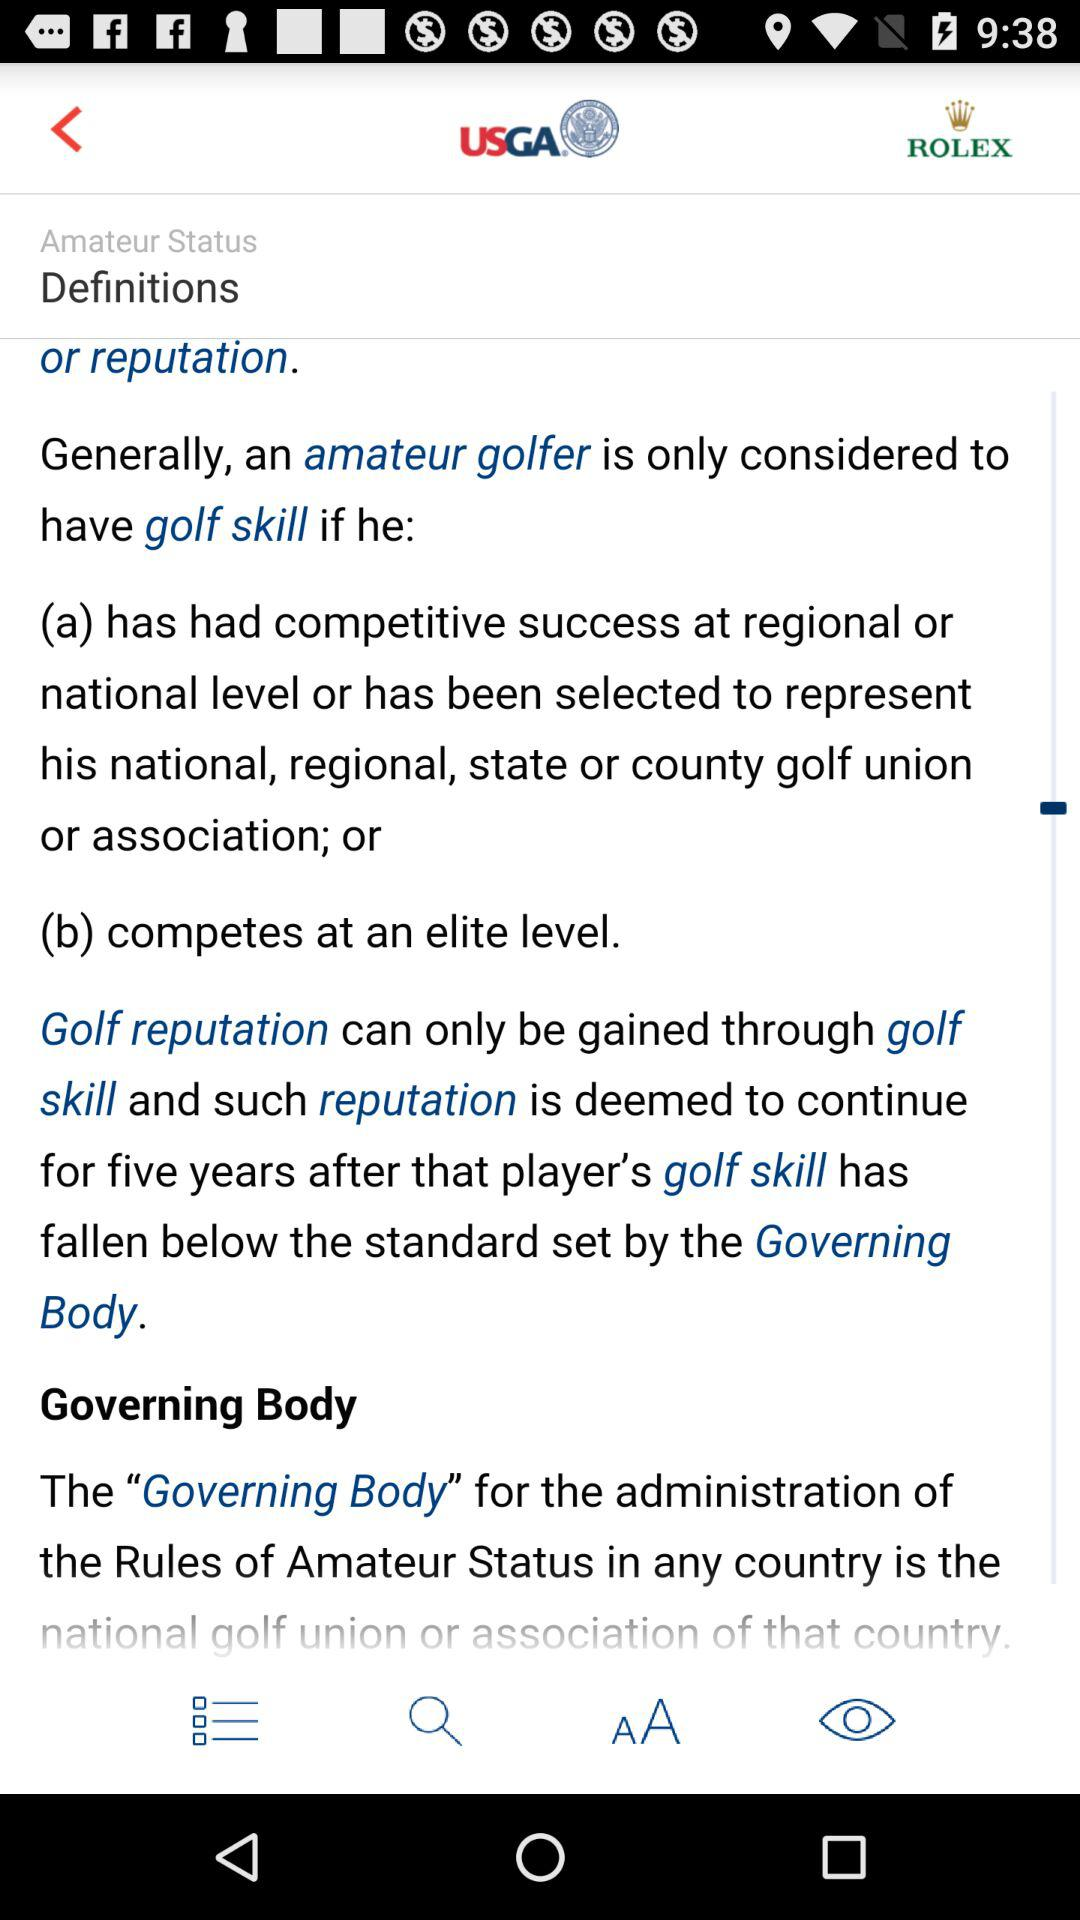What are the two levels of competitive success? The two levels of competitive success are "regional" and "national". 